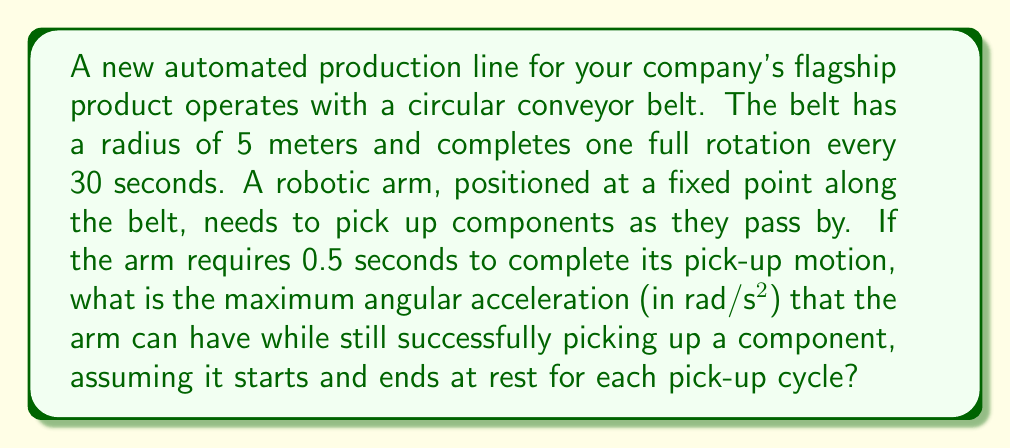Solve this math problem. To solve this problem, we need to use concepts of angular velocity and acceleration. Let's break it down step-by-step:

1) First, calculate the angular velocity (ω) of the conveyor belt:
   $$\omega = \frac{2\pi}{T} = \frac{2\pi}{30} = \frac{\pi}{15} \approx 0.2094 \text{ rad/s}$$
   where T is the period of rotation.

2) The angular distance (θ) the belt travels during the pick-up time:
   $$\theta = \omega t = \frac{\pi}{15} \cdot 0.5 = \frac{\pi}{30} \approx 0.1047 \text{ rad}$$

3) This is the maximum angular distance the robotic arm can travel to successfully pick up the component.

4) For uniform angular acceleration, we can use the equation:
   $$\theta = \frac{1}{2}\alpha t^2$$
   where α is the angular acceleration and t is the time (0.5 s).

5) Rearranging to solve for α:
   $$\alpha = \frac{2\theta}{t^2} = \frac{2 \cdot \frac{\pi}{30}}{(0.5)^2} = \frac{4\pi}{15} \approx 0.8378 \text{ rad/s}^2$$

This is the maximum angular acceleration the robotic arm can have to successfully pick up the component, assuming it starts and ends at rest for each pick-up cycle.
Answer: The maximum angular acceleration of the robotic arm is approximately 0.8378 rad/s². 